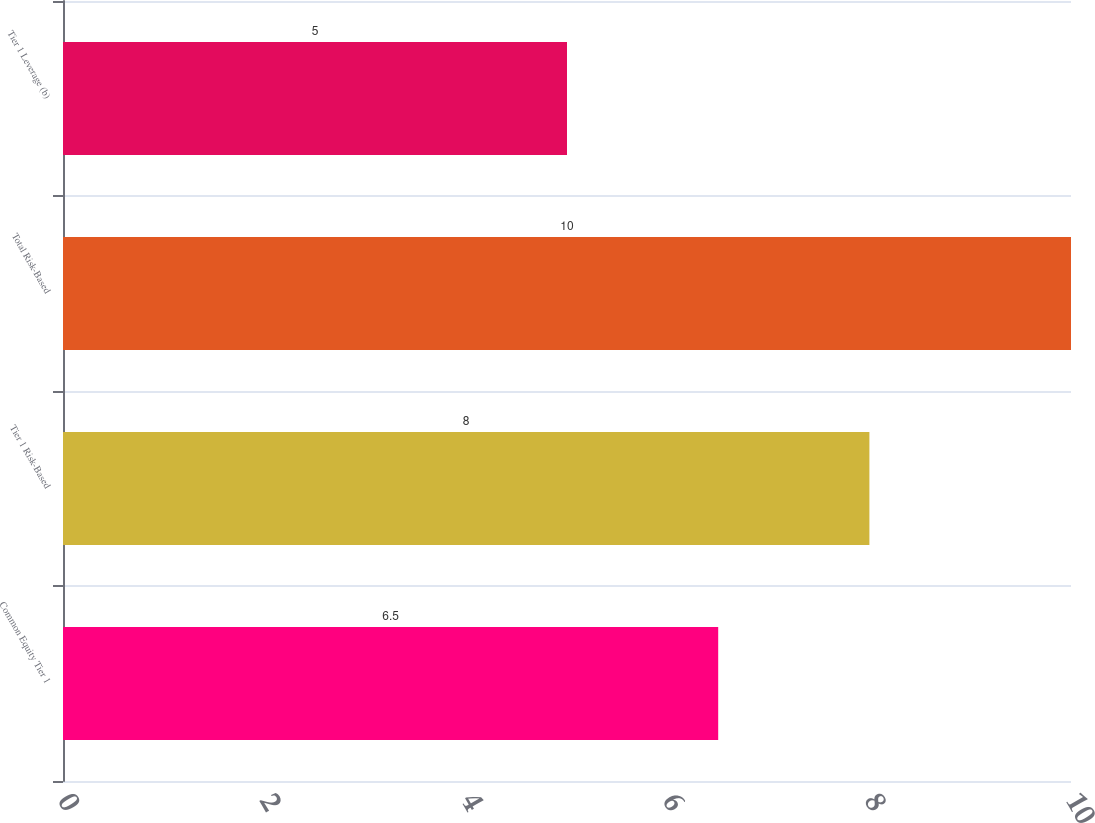Convert chart to OTSL. <chart><loc_0><loc_0><loc_500><loc_500><bar_chart><fcel>Common Equity Tier 1<fcel>Tier 1 Risk-Based<fcel>Total Risk-Based<fcel>Tier 1 Leverage (b)<nl><fcel>6.5<fcel>8<fcel>10<fcel>5<nl></chart> 